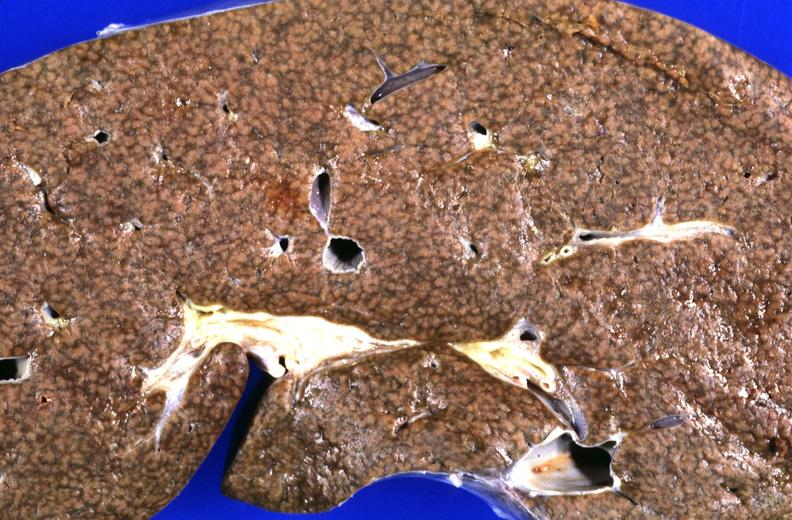how does this image show liver, cirrhosis and iron overload, chronic sickle cell disease?
Answer the question using a single word or phrase. With multiple blood transfusions 